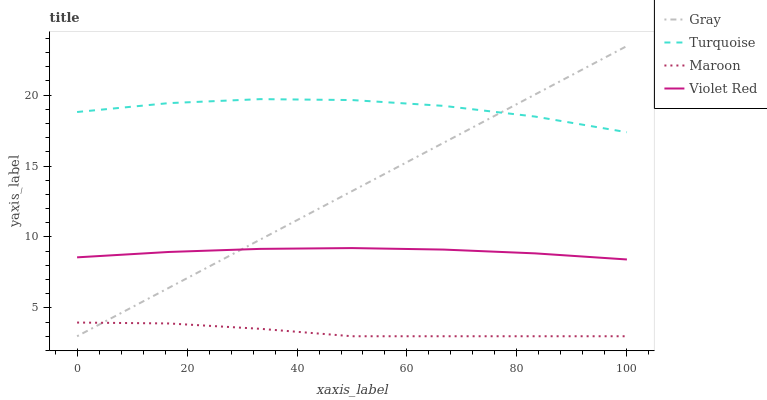Does Maroon have the minimum area under the curve?
Answer yes or no. Yes. Does Turquoise have the maximum area under the curve?
Answer yes or no. Yes. Does Violet Red have the minimum area under the curve?
Answer yes or no. No. Does Violet Red have the maximum area under the curve?
Answer yes or no. No. Is Gray the smoothest?
Answer yes or no. Yes. Is Turquoise the roughest?
Answer yes or no. Yes. Is Violet Red the smoothest?
Answer yes or no. No. Is Violet Red the roughest?
Answer yes or no. No. Does Gray have the lowest value?
Answer yes or no. Yes. Does Violet Red have the lowest value?
Answer yes or no. No. Does Gray have the highest value?
Answer yes or no. Yes. Does Turquoise have the highest value?
Answer yes or no. No. Is Violet Red less than Turquoise?
Answer yes or no. Yes. Is Violet Red greater than Maroon?
Answer yes or no. Yes. Does Gray intersect Maroon?
Answer yes or no. Yes. Is Gray less than Maroon?
Answer yes or no. No. Is Gray greater than Maroon?
Answer yes or no. No. Does Violet Red intersect Turquoise?
Answer yes or no. No. 